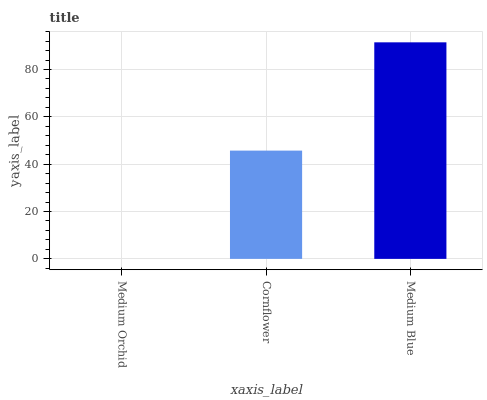Is Medium Orchid the minimum?
Answer yes or no. Yes. Is Medium Blue the maximum?
Answer yes or no. Yes. Is Cornflower the minimum?
Answer yes or no. No. Is Cornflower the maximum?
Answer yes or no. No. Is Cornflower greater than Medium Orchid?
Answer yes or no. Yes. Is Medium Orchid less than Cornflower?
Answer yes or no. Yes. Is Medium Orchid greater than Cornflower?
Answer yes or no. No. Is Cornflower less than Medium Orchid?
Answer yes or no. No. Is Cornflower the high median?
Answer yes or no. Yes. Is Cornflower the low median?
Answer yes or no. Yes. Is Medium Orchid the high median?
Answer yes or no. No. Is Medium Blue the low median?
Answer yes or no. No. 